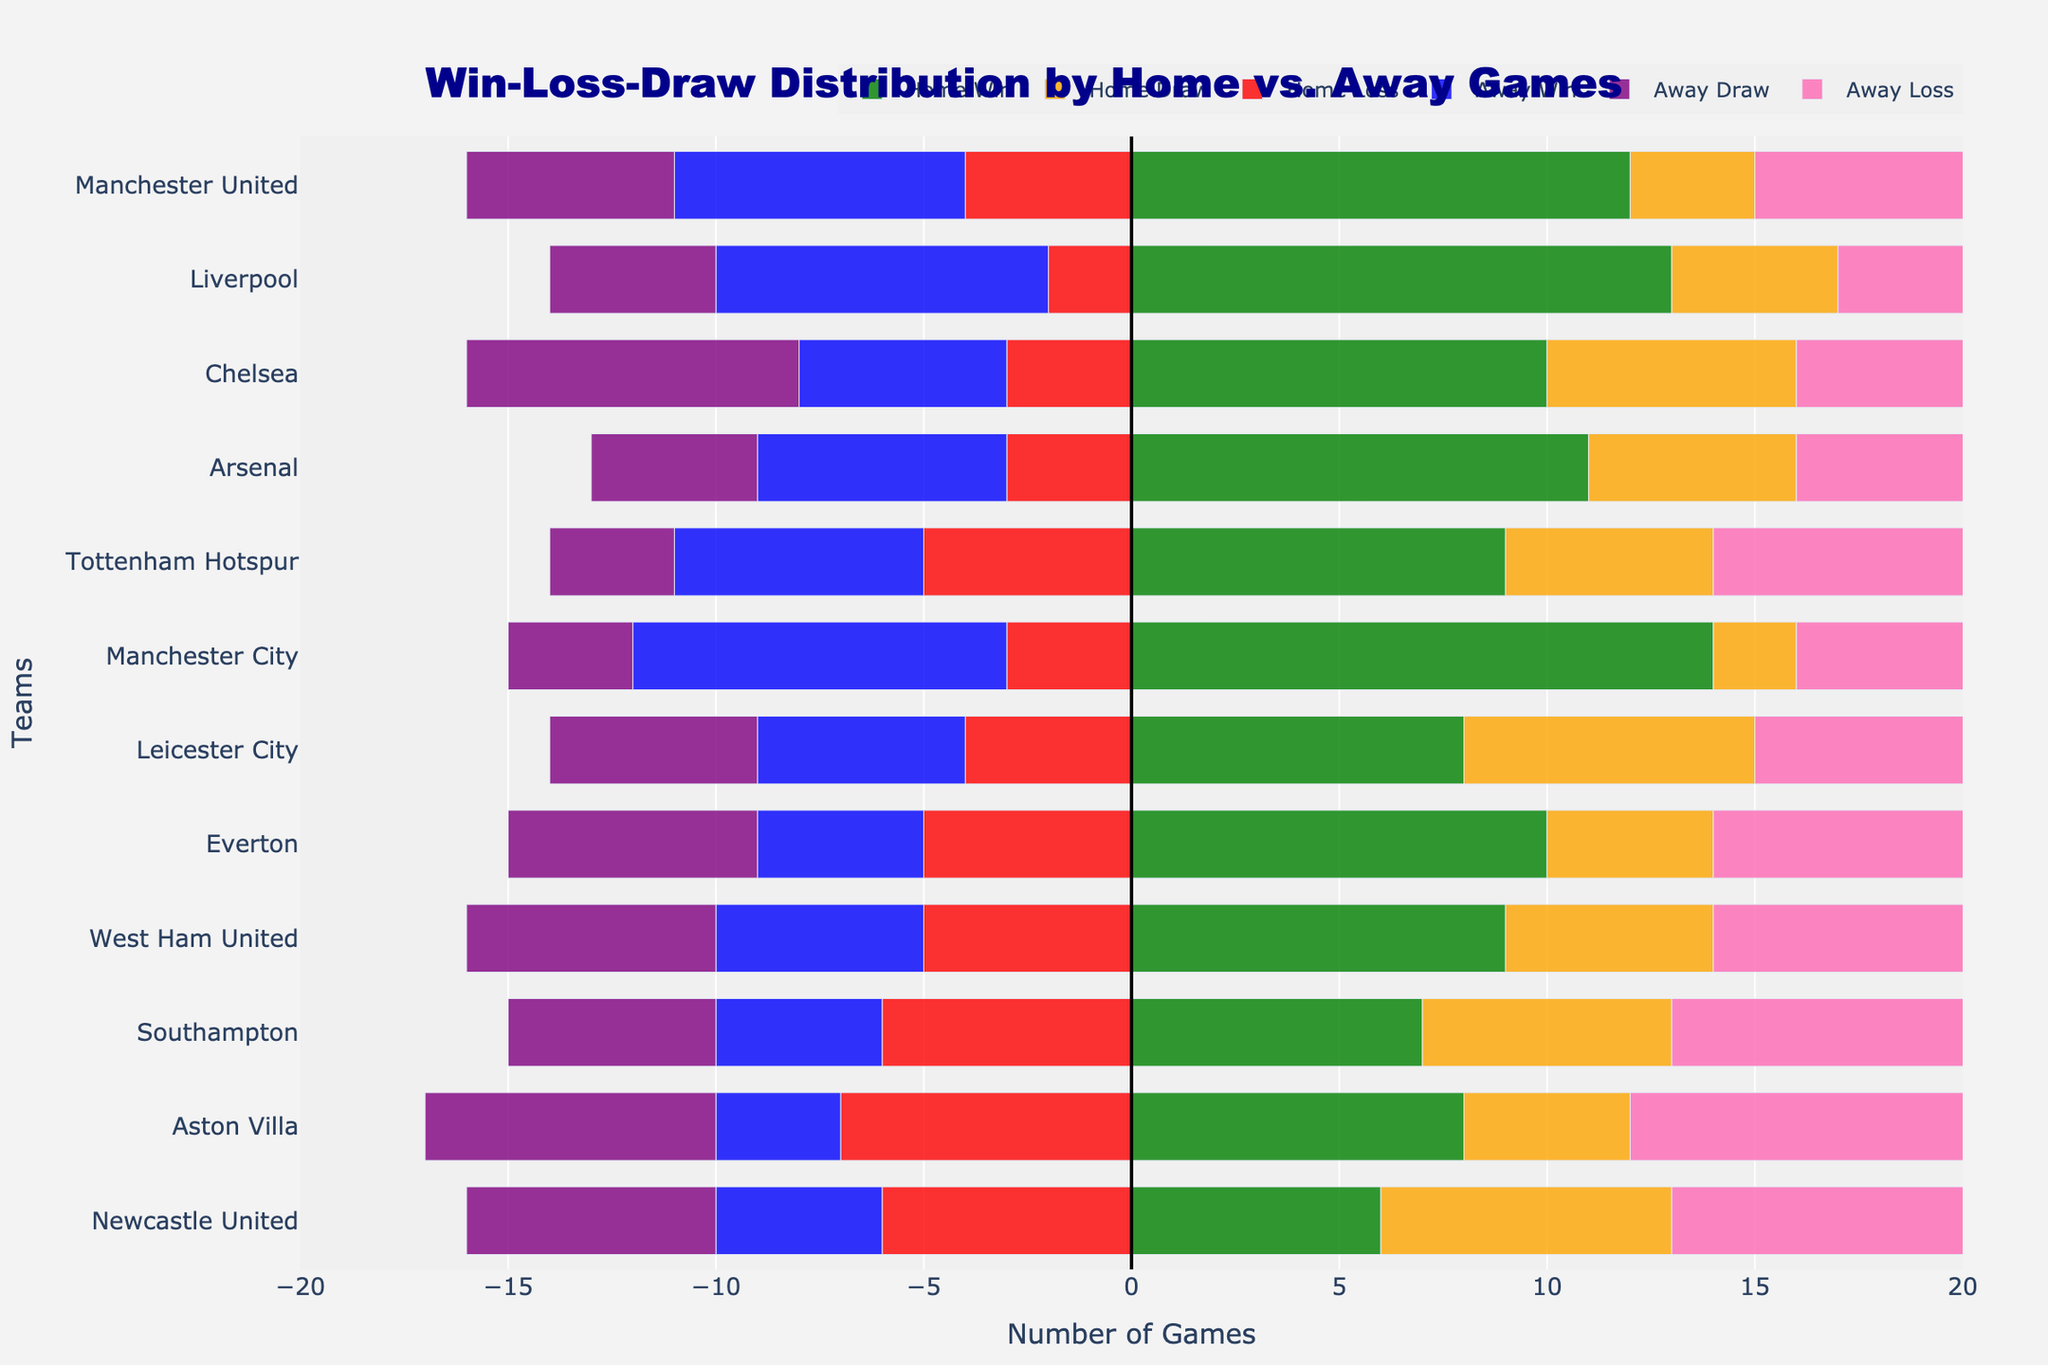How many home wins does Liverpool have compared to away wins? Liverpool has 13 home wins and 8 away wins. Comparing both, Liverpool has 13 - 8 = 5 more wins at home than away.
Answer: 5 Which team has the highest number of home wins? Check the home win bars for each team. The longest bar for home wins belongs to Manchester City, indicating the highest number of home wins at 14.
Answer: Manchester City What is the total number of games played by Manchester United at home? Add the number of home wins, draws, and losses for Manchester United: 12 (wins) + 3 (draws) + 4 (losses) = 19 games.
Answer: 19 Which team has more away losses, Arsenal or Tottenham Hotspur? Look at the bars representing away losses for both teams. Arsenal has 9 away losses while Tottenham Hotspur has 10. Compare the numbers.
Answer: Tottenham Hotspur Which team has the smallest difference between home and away wins? Calculate the difference between home and away wins for each team and find the smallest one. Leicester City has 8 home wins and 5 away wins. The difference is
Answer: Leicester City Which teams have more home draws than away draws? Compare the lengths of the bars for home draws and away draws. Teams with longer bars for home draws than away draws are Chelsea, Arsenal, Leicester City, and Southampton.
Answer: Chelsea, Arsenal, Leicester City, Southampton What's the total number of wins (home and away) for Manchester City? Add home wins and away wins of Manchester City: 14 (home) + 9 (away) = 23 wins.
Answer: 23 Which team has the highest number of draws in total? Add the home and away draws for each team, and compare. Chelsea has 6 home draws and 8 away draws, making the highest total draws of 14.
Answer: Chelsea Does West Ham United have an equal number of home and away losses? Compare the bars for home and away losses. Both home losses and away losses for West Ham United are 5.
Answer: Yes 